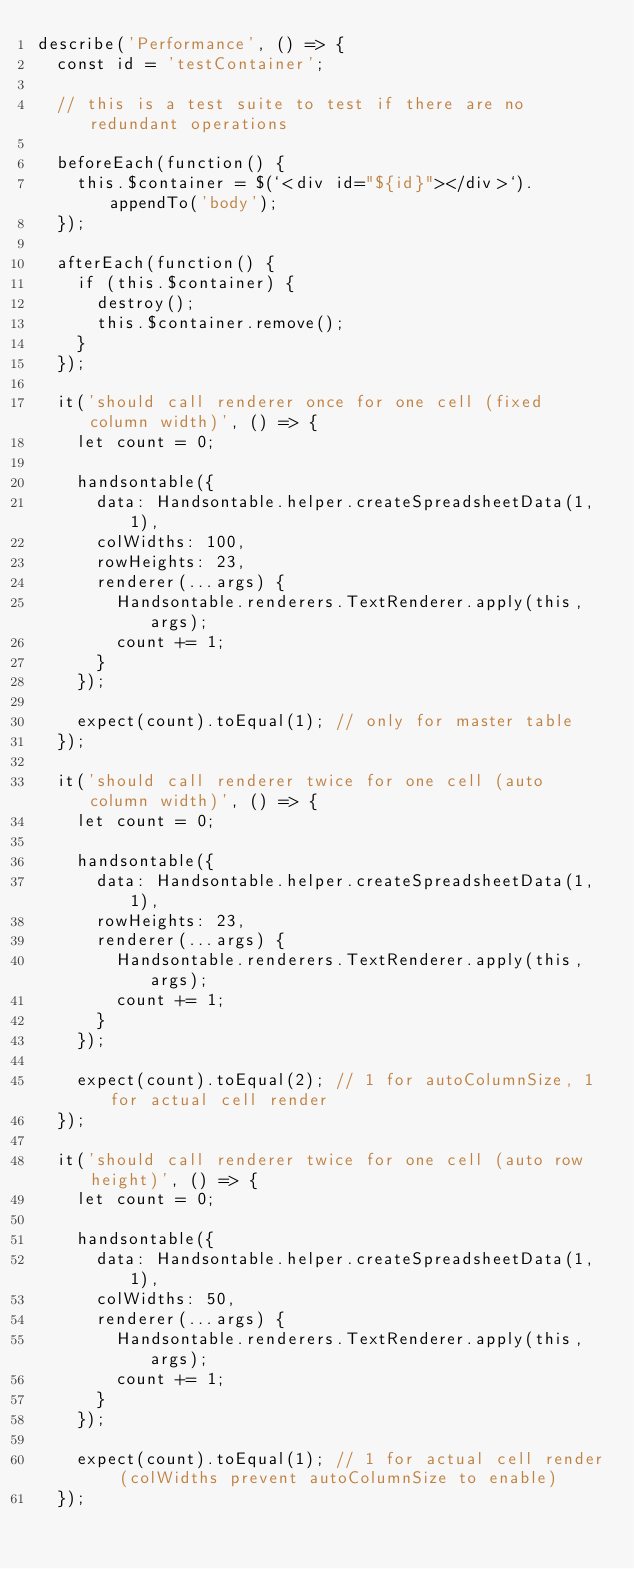<code> <loc_0><loc_0><loc_500><loc_500><_JavaScript_>describe('Performance', () => {
  const id = 'testContainer';

  // this is a test suite to test if there are no redundant operations

  beforeEach(function() {
    this.$container = $(`<div id="${id}"></div>`).appendTo('body');
  });

  afterEach(function() {
    if (this.$container) {
      destroy();
      this.$container.remove();
    }
  });

  it('should call renderer once for one cell (fixed column width)', () => {
    let count = 0;

    handsontable({
      data: Handsontable.helper.createSpreadsheetData(1, 1),
      colWidths: 100,
      rowHeights: 23,
      renderer(...args) {
        Handsontable.renderers.TextRenderer.apply(this, args);
        count += 1;
      }
    });

    expect(count).toEqual(1); // only for master table
  });

  it('should call renderer twice for one cell (auto column width)', () => {
    let count = 0;

    handsontable({
      data: Handsontable.helper.createSpreadsheetData(1, 1),
      rowHeights: 23,
      renderer(...args) {
        Handsontable.renderers.TextRenderer.apply(this, args);
        count += 1;
      }
    });

    expect(count).toEqual(2); // 1 for autoColumnSize, 1 for actual cell render
  });

  it('should call renderer twice for one cell (auto row height)', () => {
    let count = 0;

    handsontable({
      data: Handsontable.helper.createSpreadsheetData(1, 1),
      colWidths: 50,
      renderer(...args) {
        Handsontable.renderers.TextRenderer.apply(this, args);
        count += 1;
      }
    });

    expect(count).toEqual(1); // 1 for actual cell render (colWidths prevent autoColumnSize to enable)
  });
</code> 